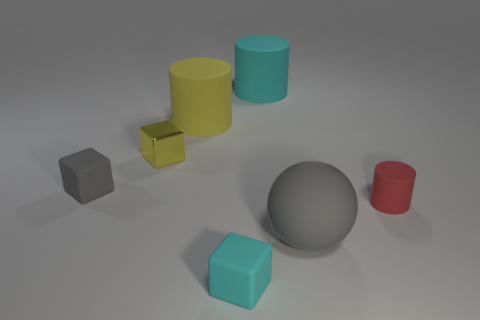Are there any other things that have the same material as the small yellow object?
Provide a succinct answer. No. Is the size of the cyan cube the same as the matte sphere?
Your answer should be very brief. No. What is the color of the cube that is behind the gray matte block?
Keep it short and to the point. Yellow. Is there a rubber thing of the same color as the tiny rubber cylinder?
Ensure brevity in your answer.  No. There is another shiny cube that is the same size as the cyan cube; what color is it?
Provide a short and direct response. Yellow. Does the small red rubber object have the same shape as the tiny cyan object?
Give a very brief answer. No. There is a cyan thing in front of the large cyan matte object; what is its material?
Your answer should be compact. Rubber. What color is the small cylinder?
Ensure brevity in your answer.  Red. Does the rubber cube that is on the right side of the gray block have the same size as the gray object that is left of the yellow metal block?
Provide a short and direct response. Yes. What size is the matte object that is both behind the small gray rubber thing and in front of the cyan cylinder?
Ensure brevity in your answer.  Large. 